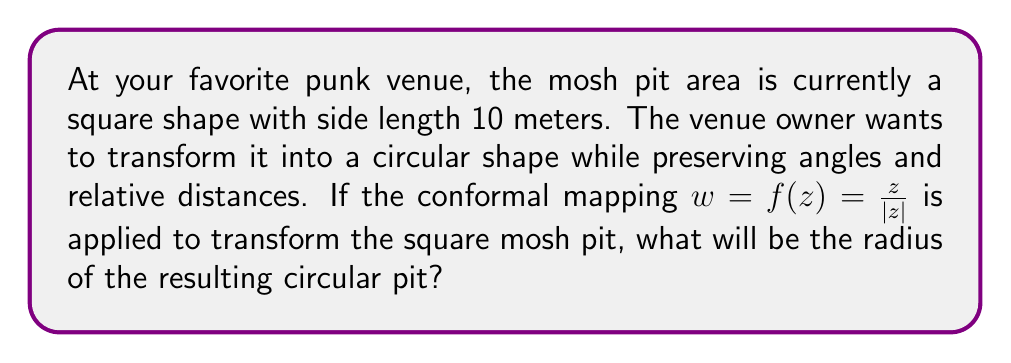Provide a solution to this math problem. Let's approach this step-by-step:

1) The given conformal mapping is $w = f(z) = \frac{z}{|z|}$. This mapping transforms points in the complex plane to points on the unit circle.

2) To transform our square mosh pit, we need to first scale it to fit within the unit circle. The square has a side length of 10 meters, so its diagonal is $10\sqrt{2}$ meters.

3) We need to scale the square so that its diagonal becomes 2 units (diameter of the unit circle). The scaling factor is:

   $s = \frac{2}{10\sqrt{2}} = \frac{1}{5\sqrt{2}}$

4) After scaling, the side length of the square becomes:

   $10 * \frac{1}{5\sqrt{2}} = \frac{2\sqrt{2}}{5}$

5) Now, we apply the conformal mapping $w = \frac{z}{|z|}$. This maps the scaled square onto the unit circle.

6) To get back to our original scale, we need to multiply by the inverse of our scaling factor:

   $r = \frac{5\sqrt{2}}{1} = 5\sqrt{2}$

Therefore, the radius of the circular mosh pit will be $5\sqrt{2}$ meters.
Answer: The radius of the resulting circular mosh pit will be $5\sqrt{2}$ meters. 